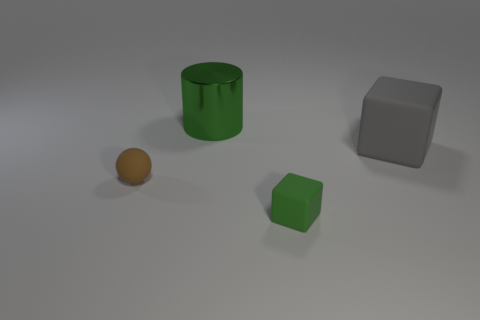Subtract all red blocks. Subtract all blue cylinders. How many blocks are left? 2 Add 3 red metal things. How many objects exist? 7 Subtract all spheres. How many objects are left? 3 Subtract 0 purple cylinders. How many objects are left? 4 Subtract all tiny green metallic cubes. Subtract all green things. How many objects are left? 2 Add 2 large green metallic things. How many large green metallic things are left? 3 Add 2 small green matte blocks. How many small green matte blocks exist? 3 